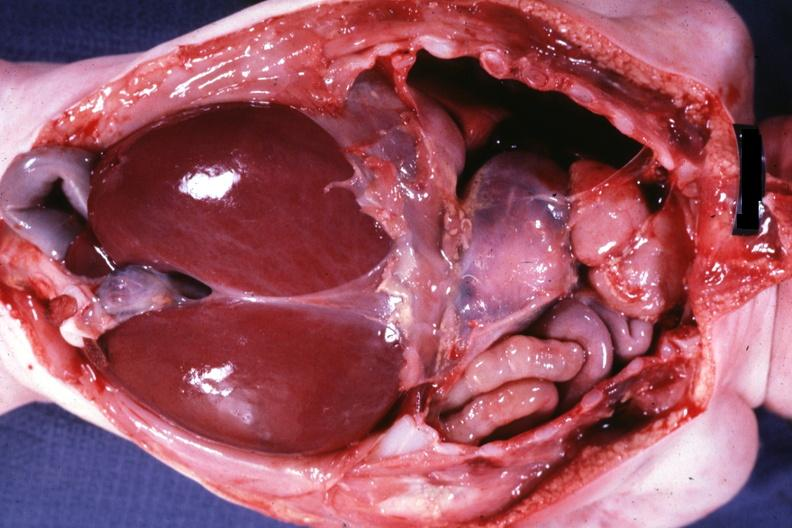what is present?
Answer the question using a single word or phrase. Muscle 